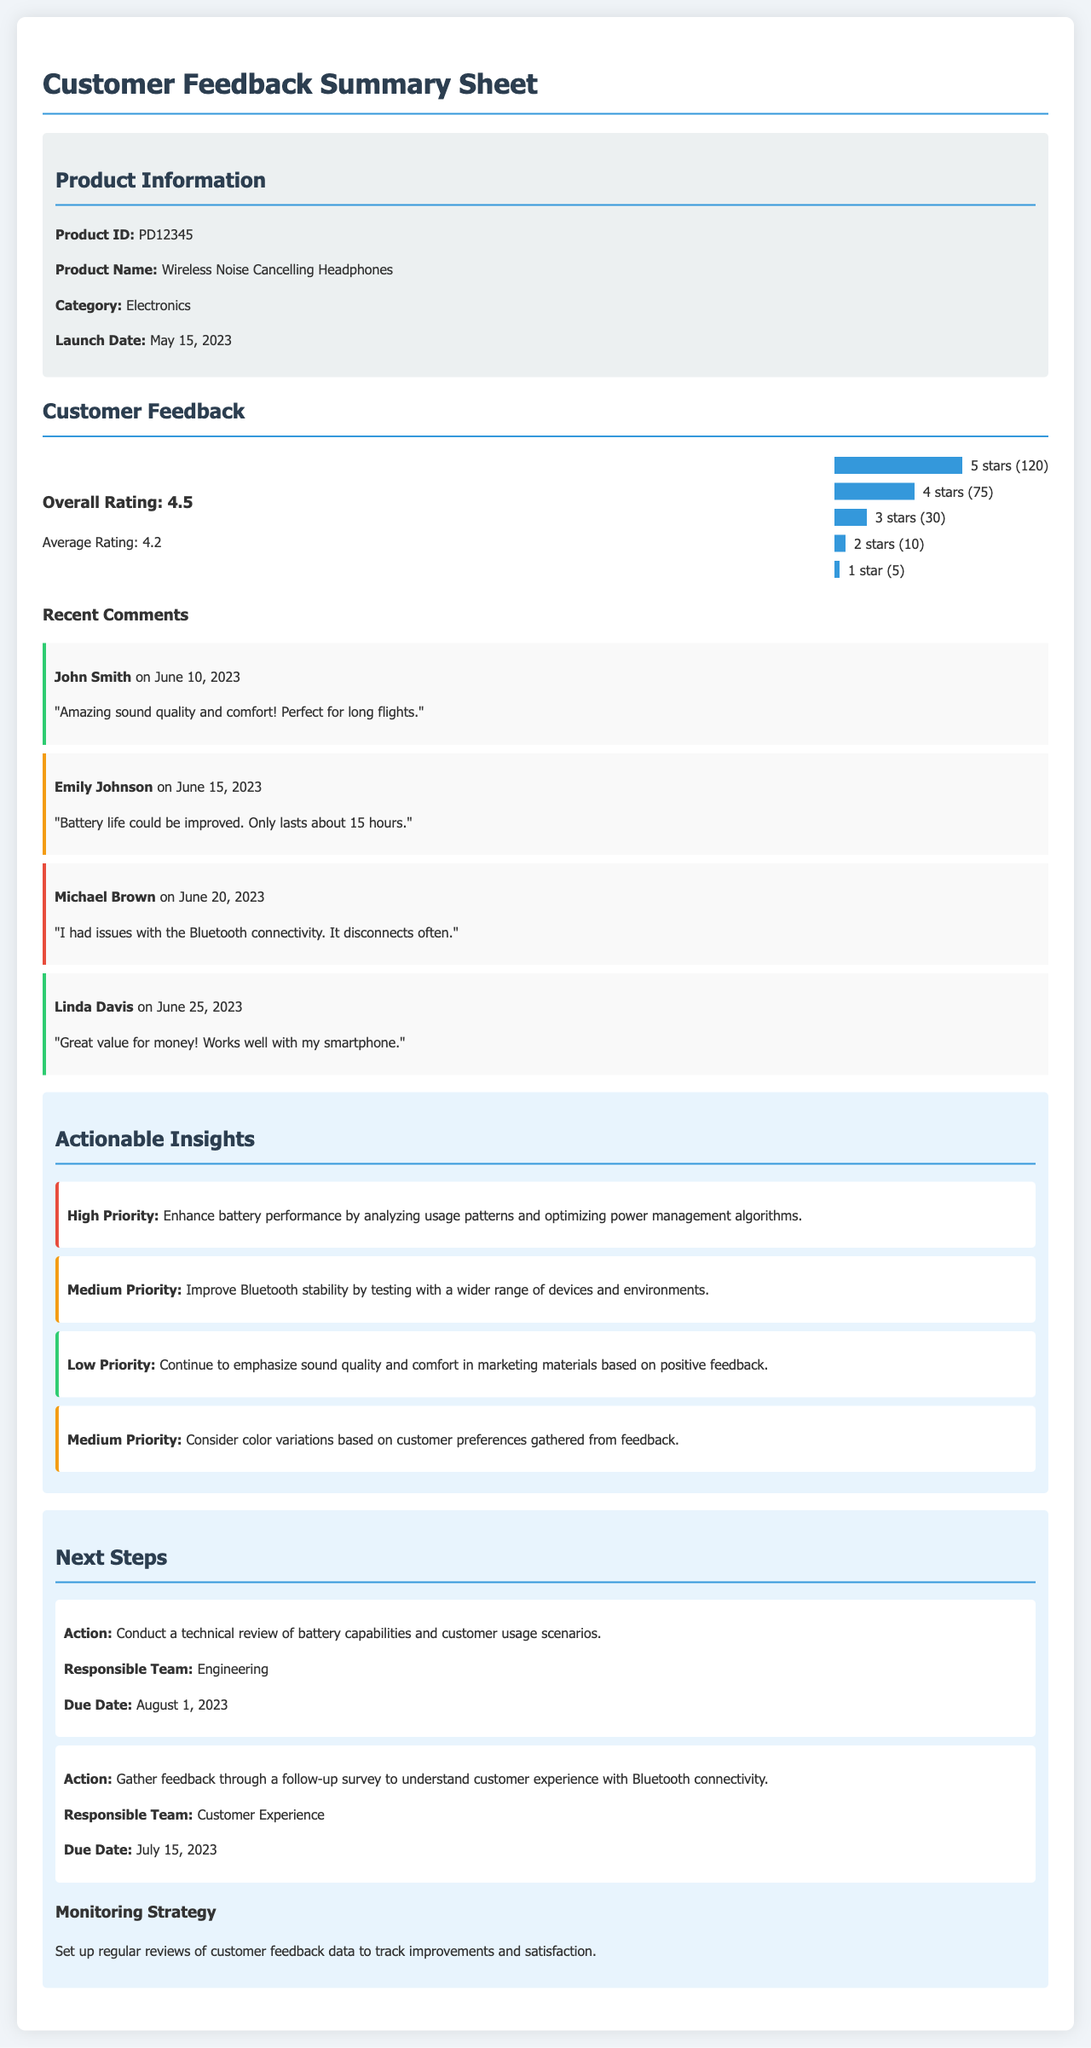What is the product name? The product name is provided in the product information section of the document.
Answer: Wireless Noise Cancelling Headphones What is the overall rating? The overall rating is mentioned near the top of the customer feedback section.
Answer: 4.5 How many comments were received with a rating of 5 stars? The number of comments for 5 stars is specified in the rating distribution section.
Answer: 120 What high-priority insight is mentioned? The high-priority insight is detailed in the actionable insights section of the document.
Answer: Enhance battery performance by analyzing usage patterns and optimizing power management algorithms Who is responsible for gathering feedback through a follow-up survey? The document specifies which team is responsible for each action in the next steps section.
Answer: Customer Experience What is the due date for the technical review of battery capabilities? The due date is given for each action outlined in the next steps section.
Answer: August 1, 2023 What was a neutral comment related to? The neutral comment provides user feedback about a specific aspect of the product.
Answer: Battery life could be improved What is the average rating reported in the document? The average rating is given alongside the overall rating as part of the customer feedback section.
Answer: 4.2 